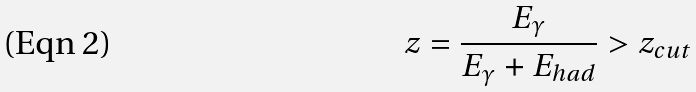<formula> <loc_0><loc_0><loc_500><loc_500>z = \frac { E _ { \gamma } } { E _ { \gamma } + E _ { h a d } } > z _ { c u t }</formula> 